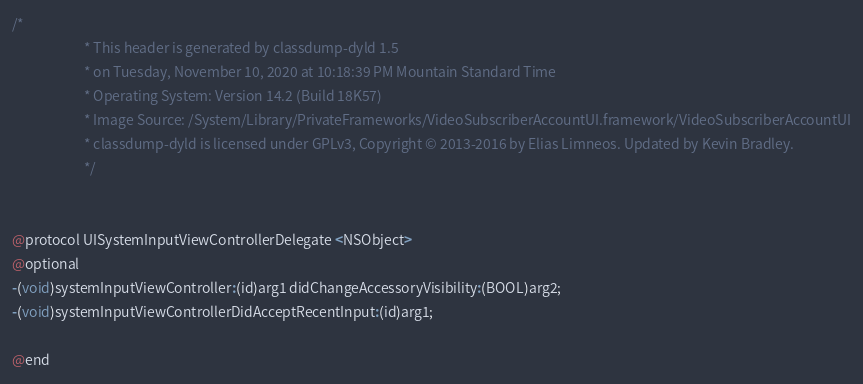<code> <loc_0><loc_0><loc_500><loc_500><_C_>/*
                       * This header is generated by classdump-dyld 1.5
                       * on Tuesday, November 10, 2020 at 10:18:39 PM Mountain Standard Time
                       * Operating System: Version 14.2 (Build 18K57)
                       * Image Source: /System/Library/PrivateFrameworks/VideoSubscriberAccountUI.framework/VideoSubscriberAccountUI
                       * classdump-dyld is licensed under GPLv3, Copyright © 2013-2016 by Elias Limneos. Updated by Kevin Bradley.
                       */


@protocol UISystemInputViewControllerDelegate <NSObject>
@optional
-(void)systemInputViewController:(id)arg1 didChangeAccessoryVisibility:(BOOL)arg2;
-(void)systemInputViewControllerDidAcceptRecentInput:(id)arg1;

@end

</code> 